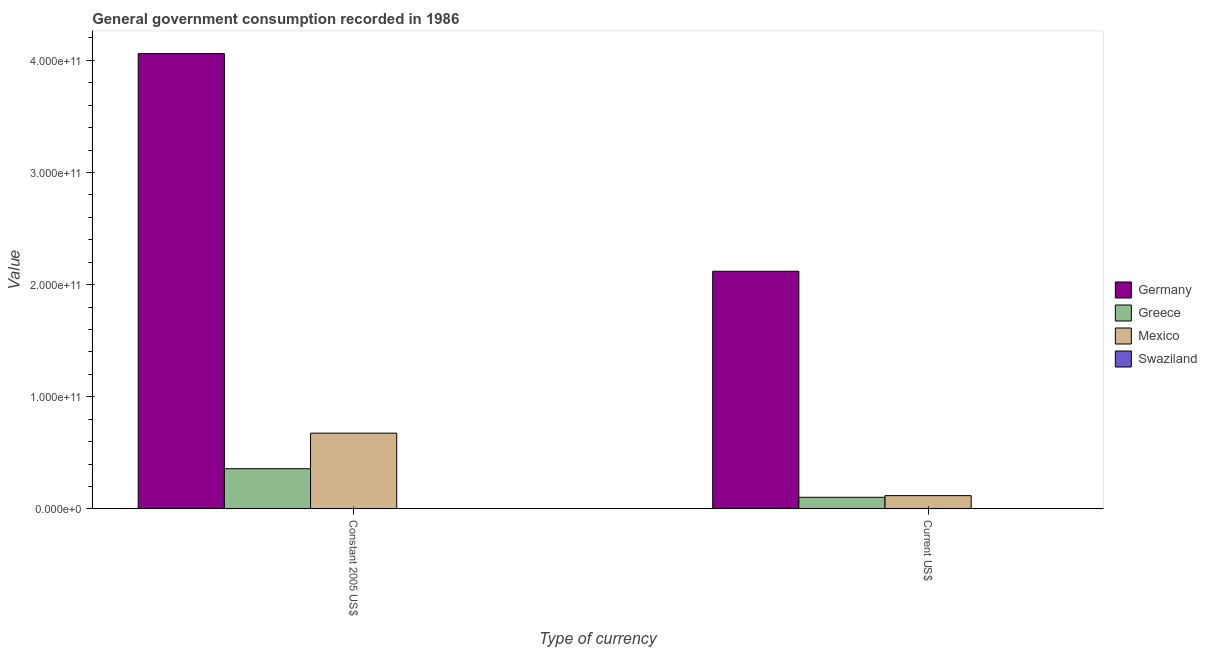How many groups of bars are there?
Your response must be concise. 2. Are the number of bars per tick equal to the number of legend labels?
Your response must be concise. Yes. How many bars are there on the 1st tick from the left?
Your response must be concise. 4. What is the label of the 1st group of bars from the left?
Your answer should be compact. Constant 2005 US$. What is the value consumed in current us$ in Germany?
Your answer should be compact. 2.12e+11. Across all countries, what is the maximum value consumed in current us$?
Provide a short and direct response. 2.12e+11. Across all countries, what is the minimum value consumed in current us$?
Ensure brevity in your answer.  9.01e+07. In which country was the value consumed in constant 2005 us$ maximum?
Keep it short and to the point. Germany. In which country was the value consumed in constant 2005 us$ minimum?
Provide a short and direct response. Swaziland. What is the total value consumed in current us$ in the graph?
Keep it short and to the point. 2.34e+11. What is the difference between the value consumed in current us$ in Mexico and that in Swaziland?
Provide a succinct answer. 1.17e+1. What is the difference between the value consumed in constant 2005 us$ in Mexico and the value consumed in current us$ in Swaziland?
Your answer should be very brief. 6.74e+1. What is the average value consumed in current us$ per country?
Provide a short and direct response. 5.85e+1. What is the difference between the value consumed in constant 2005 us$ and value consumed in current us$ in Germany?
Your answer should be very brief. 1.94e+11. What is the ratio of the value consumed in constant 2005 us$ in Mexico to that in Germany?
Your answer should be very brief. 0.17. What does the 1st bar from the right in Constant 2005 US$ represents?
Offer a terse response. Swaziland. How many bars are there?
Your answer should be very brief. 8. What is the difference between two consecutive major ticks on the Y-axis?
Provide a short and direct response. 1.00e+11. Are the values on the major ticks of Y-axis written in scientific E-notation?
Give a very brief answer. Yes. Where does the legend appear in the graph?
Ensure brevity in your answer.  Center right. How are the legend labels stacked?
Make the answer very short. Vertical. What is the title of the graph?
Provide a succinct answer. General government consumption recorded in 1986. Does "Low income" appear as one of the legend labels in the graph?
Offer a terse response. No. What is the label or title of the X-axis?
Provide a succinct answer. Type of currency. What is the label or title of the Y-axis?
Keep it short and to the point. Value. What is the Value in Germany in Constant 2005 US$?
Your answer should be compact. 4.06e+11. What is the Value in Greece in Constant 2005 US$?
Give a very brief answer. 3.58e+1. What is the Value in Mexico in Constant 2005 US$?
Offer a very short reply. 6.75e+1. What is the Value of Swaziland in Constant 2005 US$?
Offer a terse response. 1.24e+08. What is the Value in Germany in Current US$?
Make the answer very short. 2.12e+11. What is the Value of Greece in Current US$?
Offer a very short reply. 1.03e+1. What is the Value in Mexico in Current US$?
Your response must be concise. 1.18e+1. What is the Value of Swaziland in Current US$?
Your answer should be very brief. 9.01e+07. Across all Type of currency, what is the maximum Value of Germany?
Provide a succinct answer. 4.06e+11. Across all Type of currency, what is the maximum Value in Greece?
Provide a succinct answer. 3.58e+1. Across all Type of currency, what is the maximum Value of Mexico?
Make the answer very short. 6.75e+1. Across all Type of currency, what is the maximum Value in Swaziland?
Provide a succinct answer. 1.24e+08. Across all Type of currency, what is the minimum Value of Germany?
Offer a terse response. 2.12e+11. Across all Type of currency, what is the minimum Value in Greece?
Your response must be concise. 1.03e+1. Across all Type of currency, what is the minimum Value of Mexico?
Provide a succinct answer. 1.18e+1. Across all Type of currency, what is the minimum Value of Swaziland?
Your response must be concise. 9.01e+07. What is the total Value in Germany in the graph?
Make the answer very short. 6.18e+11. What is the total Value of Greece in the graph?
Make the answer very short. 4.61e+1. What is the total Value in Mexico in the graph?
Provide a short and direct response. 7.93e+1. What is the total Value in Swaziland in the graph?
Provide a short and direct response. 2.14e+08. What is the difference between the Value in Germany in Constant 2005 US$ and that in Current US$?
Provide a succinct answer. 1.94e+11. What is the difference between the Value of Greece in Constant 2005 US$ and that in Current US$?
Ensure brevity in your answer.  2.55e+1. What is the difference between the Value in Mexico in Constant 2005 US$ and that in Current US$?
Offer a terse response. 5.57e+1. What is the difference between the Value in Swaziland in Constant 2005 US$ and that in Current US$?
Offer a terse response. 3.37e+07. What is the difference between the Value in Germany in Constant 2005 US$ and the Value in Greece in Current US$?
Your answer should be very brief. 3.96e+11. What is the difference between the Value in Germany in Constant 2005 US$ and the Value in Mexico in Current US$?
Make the answer very short. 3.94e+11. What is the difference between the Value in Germany in Constant 2005 US$ and the Value in Swaziland in Current US$?
Your response must be concise. 4.06e+11. What is the difference between the Value in Greece in Constant 2005 US$ and the Value in Mexico in Current US$?
Your response must be concise. 2.40e+1. What is the difference between the Value of Greece in Constant 2005 US$ and the Value of Swaziland in Current US$?
Provide a succinct answer. 3.57e+1. What is the difference between the Value in Mexico in Constant 2005 US$ and the Value in Swaziland in Current US$?
Offer a terse response. 6.74e+1. What is the average Value of Germany per Type of currency?
Offer a terse response. 3.09e+11. What is the average Value in Greece per Type of currency?
Provide a short and direct response. 2.31e+1. What is the average Value in Mexico per Type of currency?
Provide a succinct answer. 3.96e+1. What is the average Value in Swaziland per Type of currency?
Give a very brief answer. 1.07e+08. What is the difference between the Value of Germany and Value of Greece in Constant 2005 US$?
Make the answer very short. 3.70e+11. What is the difference between the Value of Germany and Value of Mexico in Constant 2005 US$?
Provide a succinct answer. 3.39e+11. What is the difference between the Value of Germany and Value of Swaziland in Constant 2005 US$?
Your answer should be compact. 4.06e+11. What is the difference between the Value of Greece and Value of Mexico in Constant 2005 US$?
Your answer should be compact. -3.17e+1. What is the difference between the Value in Greece and Value in Swaziland in Constant 2005 US$?
Offer a terse response. 3.57e+1. What is the difference between the Value of Mexico and Value of Swaziland in Constant 2005 US$?
Ensure brevity in your answer.  6.74e+1. What is the difference between the Value in Germany and Value in Greece in Current US$?
Your answer should be compact. 2.02e+11. What is the difference between the Value of Germany and Value of Mexico in Current US$?
Offer a terse response. 2.00e+11. What is the difference between the Value in Germany and Value in Swaziland in Current US$?
Give a very brief answer. 2.12e+11. What is the difference between the Value in Greece and Value in Mexico in Current US$?
Provide a succinct answer. -1.48e+09. What is the difference between the Value in Greece and Value in Swaziland in Current US$?
Provide a short and direct response. 1.02e+1. What is the difference between the Value in Mexico and Value in Swaziland in Current US$?
Offer a very short reply. 1.17e+1. What is the ratio of the Value in Germany in Constant 2005 US$ to that in Current US$?
Provide a short and direct response. 1.92. What is the ratio of the Value in Greece in Constant 2005 US$ to that in Current US$?
Your response must be concise. 3.47. What is the ratio of the Value of Mexico in Constant 2005 US$ to that in Current US$?
Provide a succinct answer. 5.73. What is the ratio of the Value in Swaziland in Constant 2005 US$ to that in Current US$?
Provide a succinct answer. 1.37. What is the difference between the highest and the second highest Value in Germany?
Your answer should be compact. 1.94e+11. What is the difference between the highest and the second highest Value of Greece?
Your answer should be very brief. 2.55e+1. What is the difference between the highest and the second highest Value of Mexico?
Your response must be concise. 5.57e+1. What is the difference between the highest and the second highest Value in Swaziland?
Your answer should be compact. 3.37e+07. What is the difference between the highest and the lowest Value in Germany?
Ensure brevity in your answer.  1.94e+11. What is the difference between the highest and the lowest Value in Greece?
Offer a terse response. 2.55e+1. What is the difference between the highest and the lowest Value in Mexico?
Provide a short and direct response. 5.57e+1. What is the difference between the highest and the lowest Value in Swaziland?
Give a very brief answer. 3.37e+07. 